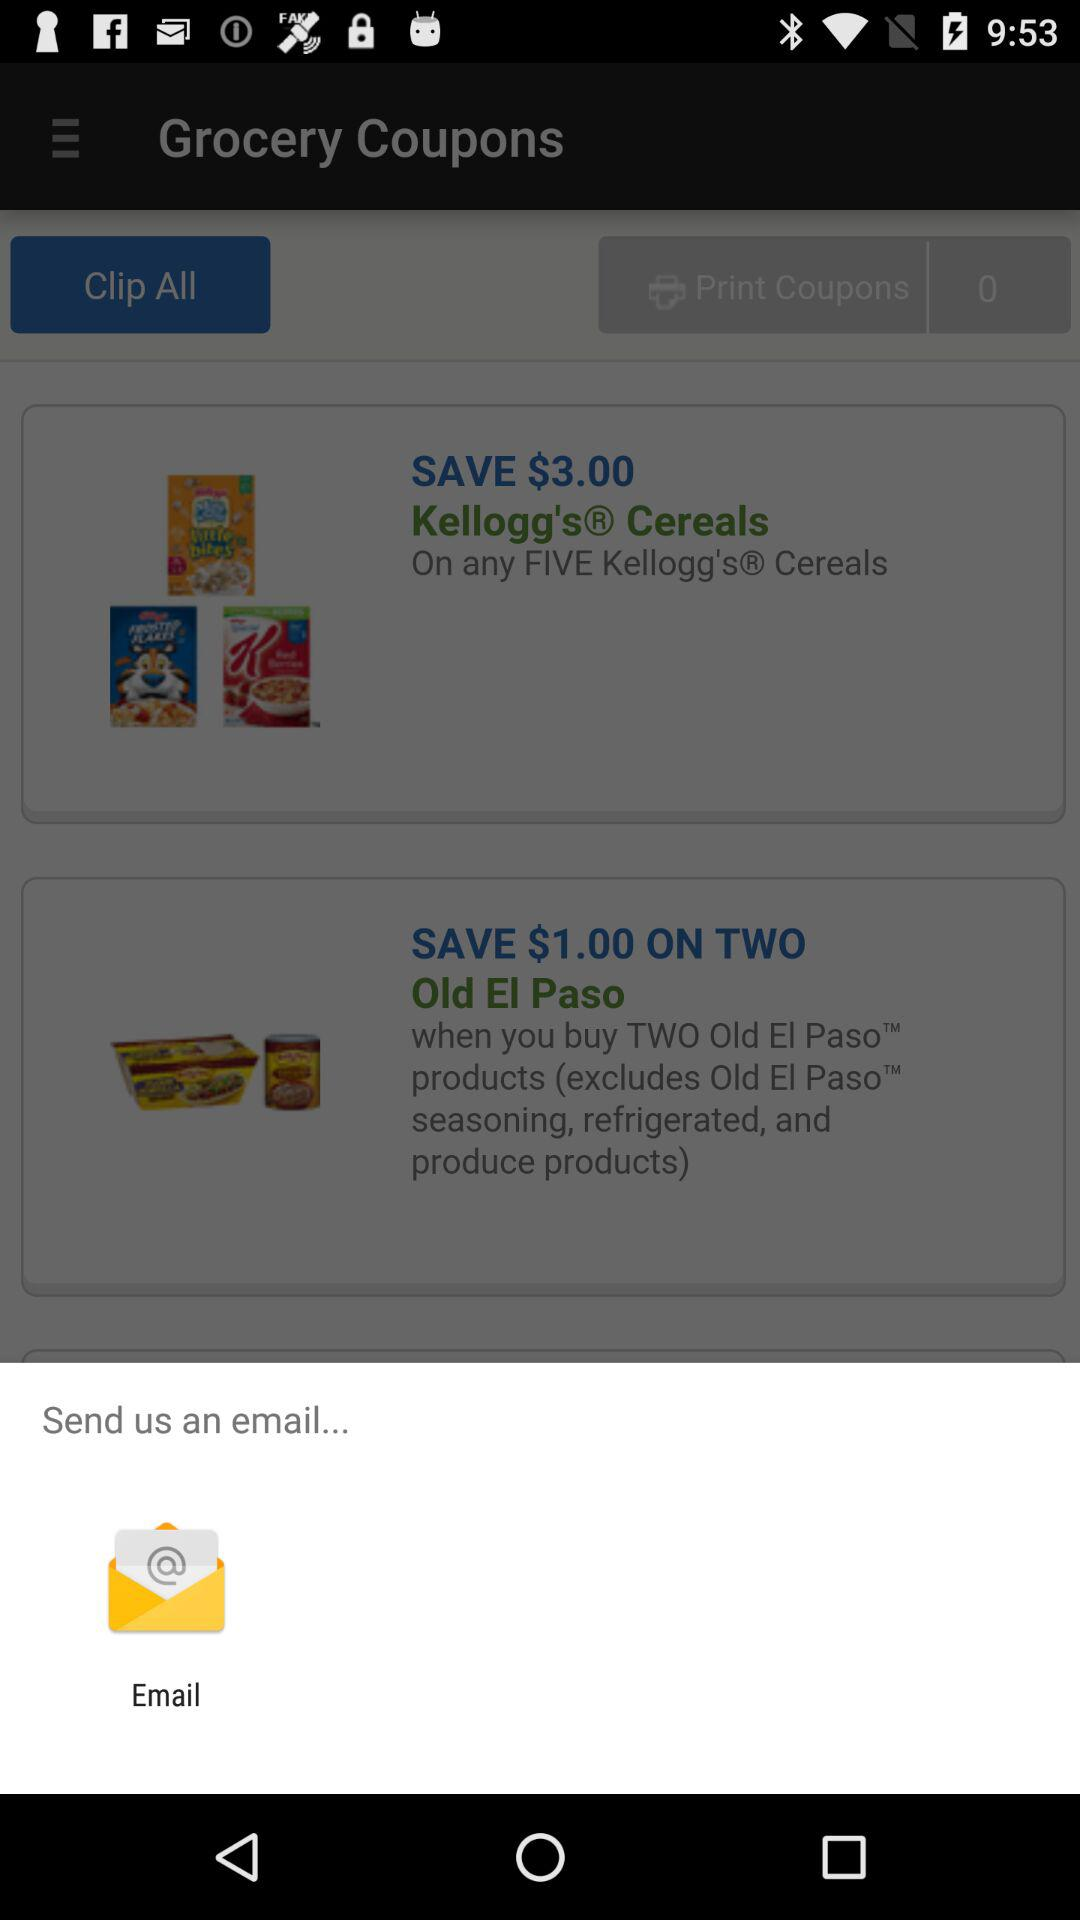What is the saving price of two old El Pasos? The saving price of two old El Pasos is $1.00. 